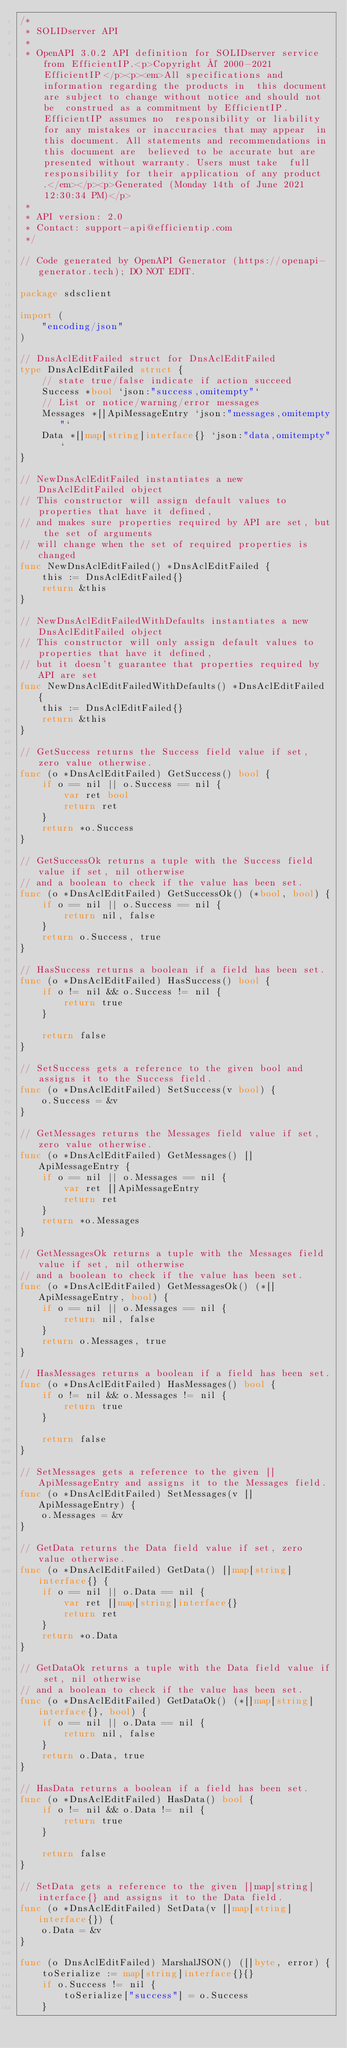<code> <loc_0><loc_0><loc_500><loc_500><_Go_>/*
 * SOLIDserver API
 *
 * OpenAPI 3.0.2 API definition for SOLIDserver service from EfficientIP.<p>Copyright © 2000-2021 EfficientIP</p><p><em>All specifications and information regarding the products in  this document are subject to change without notice and should not be  construed as a commitment by EfficientIP. EfficientIP assumes no  responsibility or liability for any mistakes or inaccuracies that may appear  in this document. All statements and recommendations in this document are  believed to be accurate but are presented without warranty. Users must take  full responsibility for their application of any product.</em></p><p>Generated (Monday 14th of June 2021 12:30:34 PM)</p>
 *
 * API version: 2.0
 * Contact: support-api@efficientip.com
 */

// Code generated by OpenAPI Generator (https://openapi-generator.tech); DO NOT EDIT.

package sdsclient

import (
	"encoding/json"
)

// DnsAclEditFailed struct for DnsAclEditFailed
type DnsAclEditFailed struct {
	// state true/false indicate if action succeed
	Success *bool `json:"success,omitempty"`
	// List or notice/warning/error messages
	Messages *[]ApiMessageEntry `json:"messages,omitempty"`
	Data *[]map[string]interface{} `json:"data,omitempty"`
}

// NewDnsAclEditFailed instantiates a new DnsAclEditFailed object
// This constructor will assign default values to properties that have it defined,
// and makes sure properties required by API are set, but the set of arguments
// will change when the set of required properties is changed
func NewDnsAclEditFailed() *DnsAclEditFailed {
	this := DnsAclEditFailed{}
	return &this
}

// NewDnsAclEditFailedWithDefaults instantiates a new DnsAclEditFailed object
// This constructor will only assign default values to properties that have it defined,
// but it doesn't guarantee that properties required by API are set
func NewDnsAclEditFailedWithDefaults() *DnsAclEditFailed {
	this := DnsAclEditFailed{}
	return &this
}

// GetSuccess returns the Success field value if set, zero value otherwise.
func (o *DnsAclEditFailed) GetSuccess() bool {
	if o == nil || o.Success == nil {
		var ret bool
		return ret
	}
	return *o.Success
}

// GetSuccessOk returns a tuple with the Success field value if set, nil otherwise
// and a boolean to check if the value has been set.
func (o *DnsAclEditFailed) GetSuccessOk() (*bool, bool) {
	if o == nil || o.Success == nil {
		return nil, false
	}
	return o.Success, true
}

// HasSuccess returns a boolean if a field has been set.
func (o *DnsAclEditFailed) HasSuccess() bool {
	if o != nil && o.Success != nil {
		return true
	}

	return false
}

// SetSuccess gets a reference to the given bool and assigns it to the Success field.
func (o *DnsAclEditFailed) SetSuccess(v bool) {
	o.Success = &v
}

// GetMessages returns the Messages field value if set, zero value otherwise.
func (o *DnsAclEditFailed) GetMessages() []ApiMessageEntry {
	if o == nil || o.Messages == nil {
		var ret []ApiMessageEntry
		return ret
	}
	return *o.Messages
}

// GetMessagesOk returns a tuple with the Messages field value if set, nil otherwise
// and a boolean to check if the value has been set.
func (o *DnsAclEditFailed) GetMessagesOk() (*[]ApiMessageEntry, bool) {
	if o == nil || o.Messages == nil {
		return nil, false
	}
	return o.Messages, true
}

// HasMessages returns a boolean if a field has been set.
func (o *DnsAclEditFailed) HasMessages() bool {
	if o != nil && o.Messages != nil {
		return true
	}

	return false
}

// SetMessages gets a reference to the given []ApiMessageEntry and assigns it to the Messages field.
func (o *DnsAclEditFailed) SetMessages(v []ApiMessageEntry) {
	o.Messages = &v
}

// GetData returns the Data field value if set, zero value otherwise.
func (o *DnsAclEditFailed) GetData() []map[string]interface{} {
	if o == nil || o.Data == nil {
		var ret []map[string]interface{}
		return ret
	}
	return *o.Data
}

// GetDataOk returns a tuple with the Data field value if set, nil otherwise
// and a boolean to check if the value has been set.
func (o *DnsAclEditFailed) GetDataOk() (*[]map[string]interface{}, bool) {
	if o == nil || o.Data == nil {
		return nil, false
	}
	return o.Data, true
}

// HasData returns a boolean if a field has been set.
func (o *DnsAclEditFailed) HasData() bool {
	if o != nil && o.Data != nil {
		return true
	}

	return false
}

// SetData gets a reference to the given []map[string]interface{} and assigns it to the Data field.
func (o *DnsAclEditFailed) SetData(v []map[string]interface{}) {
	o.Data = &v
}

func (o DnsAclEditFailed) MarshalJSON() ([]byte, error) {
	toSerialize := map[string]interface{}{}
	if o.Success != nil {
		toSerialize["success"] = o.Success
	}</code> 